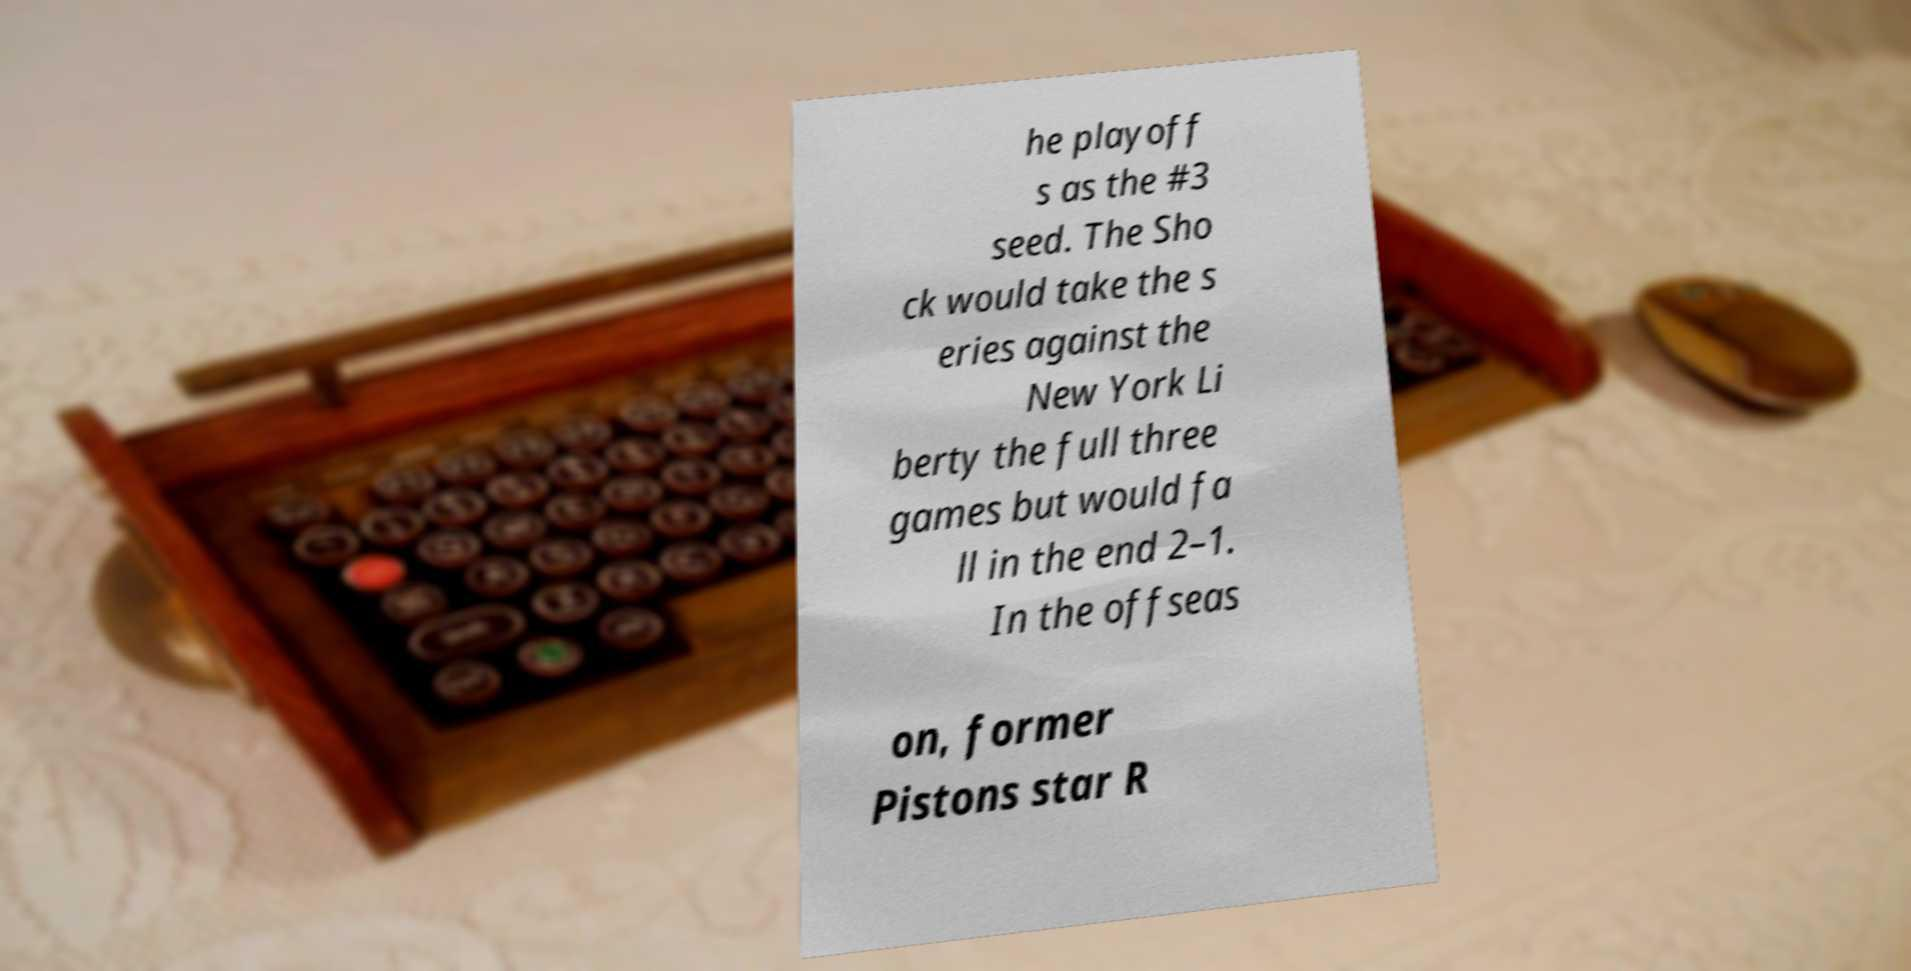For documentation purposes, I need the text within this image transcribed. Could you provide that? he playoff s as the #3 seed. The Sho ck would take the s eries against the New York Li berty the full three games but would fa ll in the end 2–1. In the offseas on, former Pistons star R 